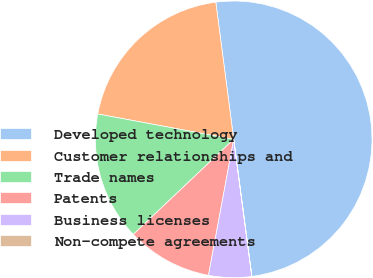Convert chart to OTSL. <chart><loc_0><loc_0><loc_500><loc_500><pie_chart><fcel>Developed technology<fcel>Customer relationships and<fcel>Trade names<fcel>Patents<fcel>Business licenses<fcel>Non-compete agreements<nl><fcel>49.97%<fcel>20.0%<fcel>15.0%<fcel>10.01%<fcel>5.01%<fcel>0.01%<nl></chart> 